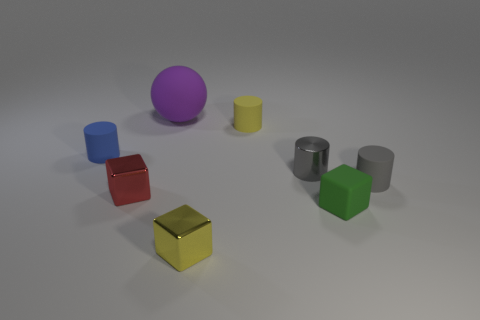Is there anything else that has the same size as the purple object?
Your response must be concise. No. Is the size of the gray matte object the same as the purple rubber thing?
Provide a succinct answer. No. There is a rubber cube; is it the same size as the ball behind the yellow block?
Keep it short and to the point. No. There is a yellow thing in front of the tiny yellow object that is behind the tiny metal block that is behind the small rubber cube; how big is it?
Make the answer very short. Small. There is another cylinder that is the same color as the tiny metal cylinder; what is its material?
Your response must be concise. Rubber. What is the material of the blue cylinder that is the same size as the green rubber object?
Your answer should be very brief. Rubber. Does the tiny object that is behind the small blue cylinder have the same material as the gray cylinder that is left of the small green thing?
Make the answer very short. No. The green matte object that is the same size as the blue cylinder is what shape?
Ensure brevity in your answer.  Cube. How many other things are there of the same color as the metal cylinder?
Offer a terse response. 1. There is a cube that is right of the tiny yellow rubber cylinder; what color is it?
Offer a terse response. Green. 